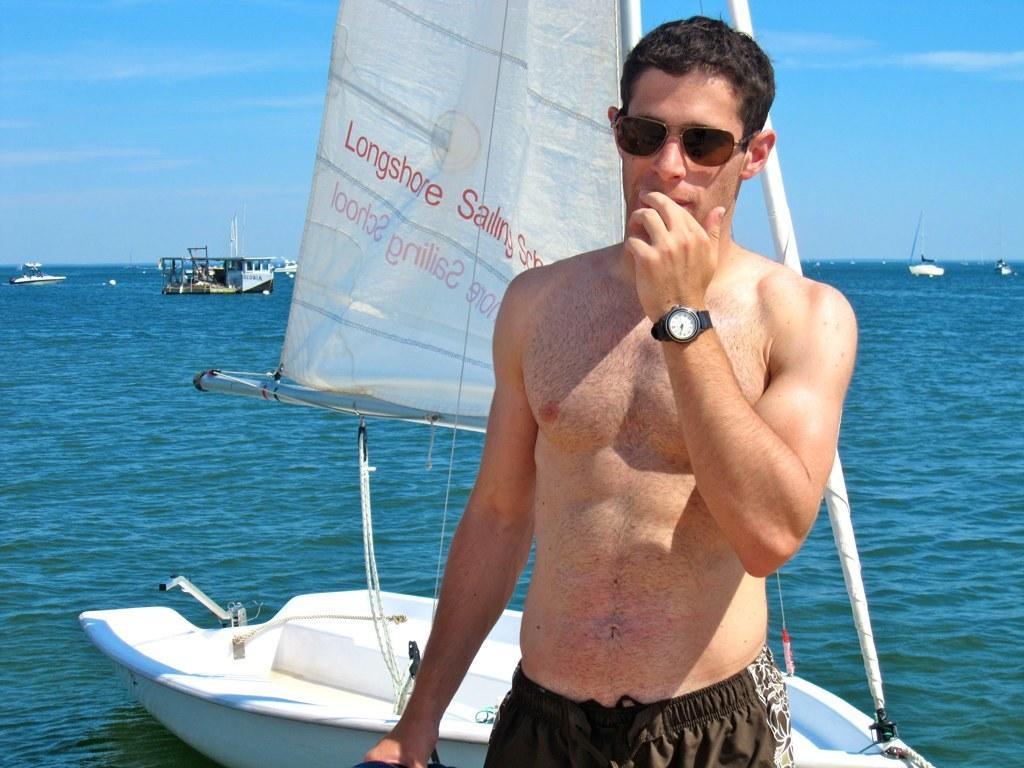Describe this image in one or two sentences. In the picture I can see man is standing. The man is wearing shades and a watch. In the background I can see boats on the water and the sky. 